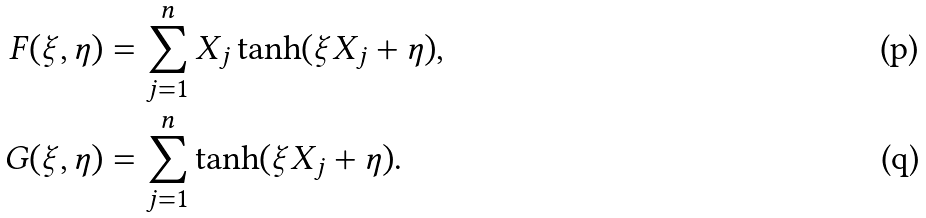<formula> <loc_0><loc_0><loc_500><loc_500>F ( \xi , \eta ) & = \sum _ { j = 1 } ^ { n } X _ { j } \tanh ( \xi X _ { j } + \eta ) , \\ G ( \xi , \eta ) & = \sum _ { j = 1 } ^ { n } \tanh ( \xi X _ { j } + \eta ) .</formula> 